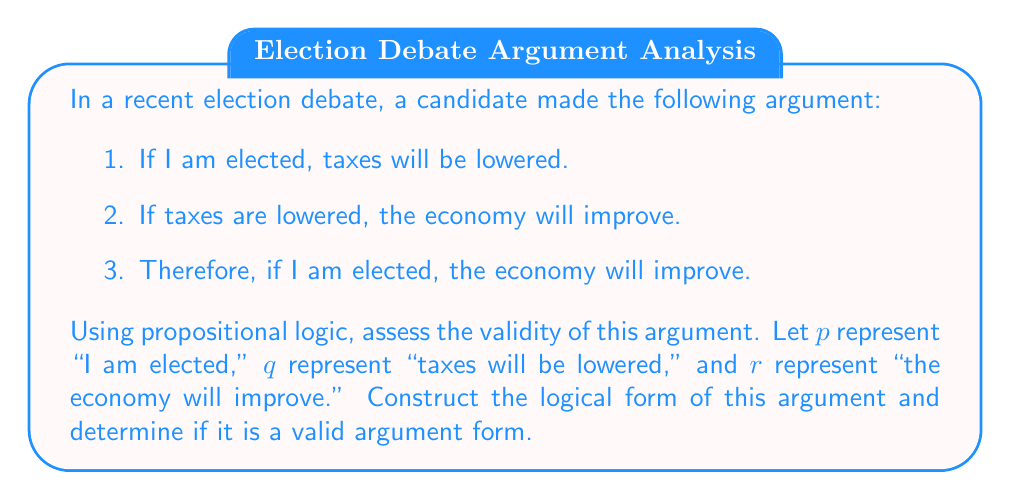Solve this math problem. To assess the validity of this argument using propositional logic, we need to follow these steps:

1. Identify the premises and conclusion:
   Premise 1: $p \rightarrow q$ (If I am elected, taxes will be lowered)
   Premise 2: $q \rightarrow r$ (If taxes are lowered, the economy will improve)
   Conclusion: $p \rightarrow r$ (If I am elected, the economy will improve)

2. Construct the logical form of the argument:
   $$
   \begin{align}
   &p \rightarrow q \\
   &q \rightarrow r \\
   \therefore \; &p \rightarrow r
   \end{align}
   $$

3. Recognize the argument form:
   This argument form is known as the hypothetical syllogism or the chain argument.

4. Assess the validity:
   To determine if this argument form is valid, we can use a truth table or consider the definition of validity. An argument is valid if and only if it is impossible for the premises to be true and the conclusion false.

   Let's consider all possible truth value combinations:

   $$
   \begin{array}{ccc|ccc}
   p & q & r & p \rightarrow q & q \rightarrow r & p \rightarrow r \\
   \hline
   T & T & T & T & T & T \\
   T & T & F & T & F & F \\
   T & F & T & F & T & T \\
   T & F & F & F & T & F \\
   F & T & T & T & T & T \\
   F & T & F & T & F & T \\
   F & F & T & T & T & T \\
   F & F & F & T & T & T \\
   \end{array}
   $$

   As we can see from the truth table, whenever both premises ($p \rightarrow q$ and $q \rightarrow r$) are true, the conclusion ($p \rightarrow r$) is also true. There is no row where both premises are true and the conclusion is false.

5. Conclusion:
   The argument form is valid. This means that if the premises are true, the conclusion must also be true. However, it's important to note that validity doesn't guarantee the truth of the premises or the conclusion in reality. An anthropologist studying election debates would be interested in how candidates use such logical structures to present their arguments, regardless of the actual truth of the statements.
Answer: The argument is valid. The logical form of the argument is a hypothetical syllogism, which is a valid argument form in propositional logic. 